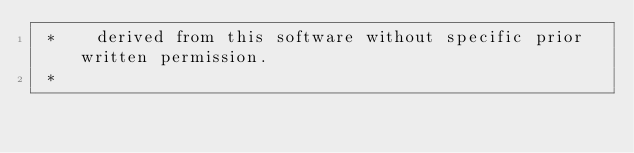Convert code to text. <code><loc_0><loc_0><loc_500><loc_500><_C_> *    derived from this software without specific prior written permission.
 *</code> 